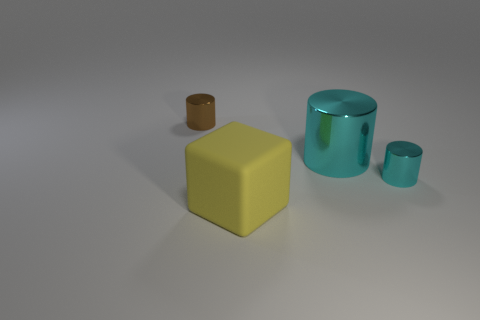Subtract all blue cubes. Subtract all blue balls. How many cubes are left? 1 Add 2 large matte things. How many objects exist? 6 Subtract all cylinders. How many objects are left? 1 Add 2 small brown metallic cylinders. How many small brown metallic cylinders exist? 3 Subtract 0 red cylinders. How many objects are left? 4 Subtract all big cyan metallic cylinders. Subtract all rubber cubes. How many objects are left? 2 Add 2 tiny metal things. How many tiny metal things are left? 4 